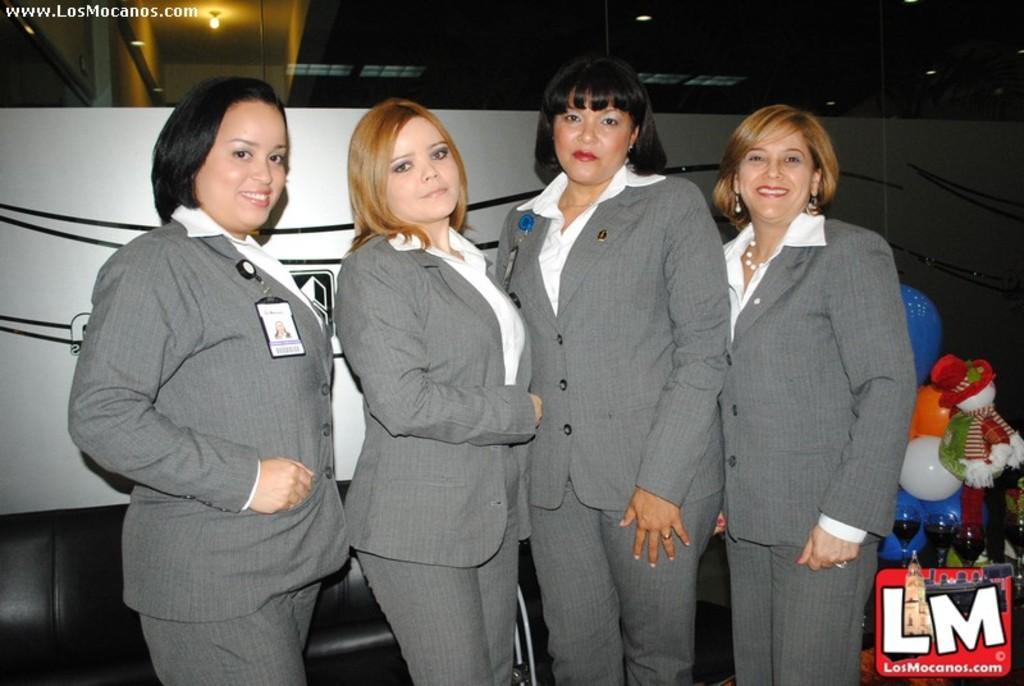Describe this image in one or two sentences. The image is taken from some website and there are a group of women standing in the front and posing for the photo, behind the women on the right side there are three glasses filled some drinks and behind the glasses there is a toy and balloons. 